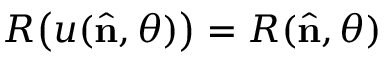Convert formula to latex. <formula><loc_0><loc_0><loc_500><loc_500>R \left ( u ( { \hat { n } } , \theta ) \right ) = R ( { \hat { n } } , \theta )</formula> 